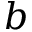Convert formula to latex. <formula><loc_0><loc_0><loc_500><loc_500>b</formula> 